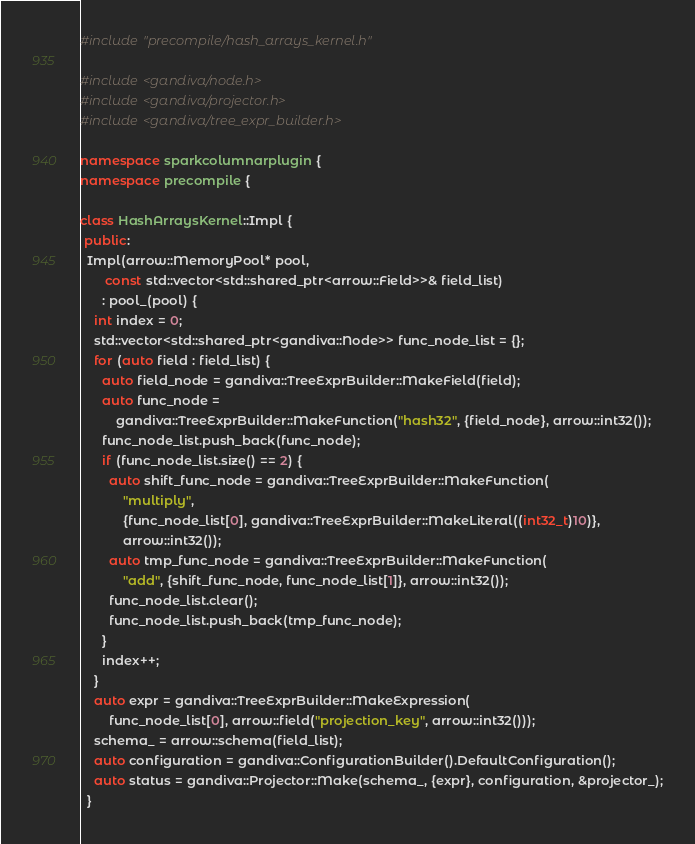Convert code to text. <code><loc_0><loc_0><loc_500><loc_500><_C++_>#include "precompile/hash_arrays_kernel.h"

#include <gandiva/node.h>
#include <gandiva/projector.h>
#include <gandiva/tree_expr_builder.h>

namespace sparkcolumnarplugin {
namespace precompile {

class HashArraysKernel::Impl {
 public:
  Impl(arrow::MemoryPool* pool,
       const std::vector<std::shared_ptr<arrow::Field>>& field_list)
      : pool_(pool) {
    int index = 0;
    std::vector<std::shared_ptr<gandiva::Node>> func_node_list = {};
    for (auto field : field_list) {
      auto field_node = gandiva::TreeExprBuilder::MakeField(field);
      auto func_node =
          gandiva::TreeExprBuilder::MakeFunction("hash32", {field_node}, arrow::int32());
      func_node_list.push_back(func_node);
      if (func_node_list.size() == 2) {
        auto shift_func_node = gandiva::TreeExprBuilder::MakeFunction(
            "multiply",
            {func_node_list[0], gandiva::TreeExprBuilder::MakeLiteral((int32_t)10)},
            arrow::int32());
        auto tmp_func_node = gandiva::TreeExprBuilder::MakeFunction(
            "add", {shift_func_node, func_node_list[1]}, arrow::int32());
        func_node_list.clear();
        func_node_list.push_back(tmp_func_node);
      }
      index++;
    }
    auto expr = gandiva::TreeExprBuilder::MakeExpression(
        func_node_list[0], arrow::field("projection_key", arrow::int32()));
    schema_ = arrow::schema(field_list);
    auto configuration = gandiva::ConfigurationBuilder().DefaultConfiguration();
    auto status = gandiva::Projector::Make(schema_, {expr}, configuration, &projector_);
  }
</code> 